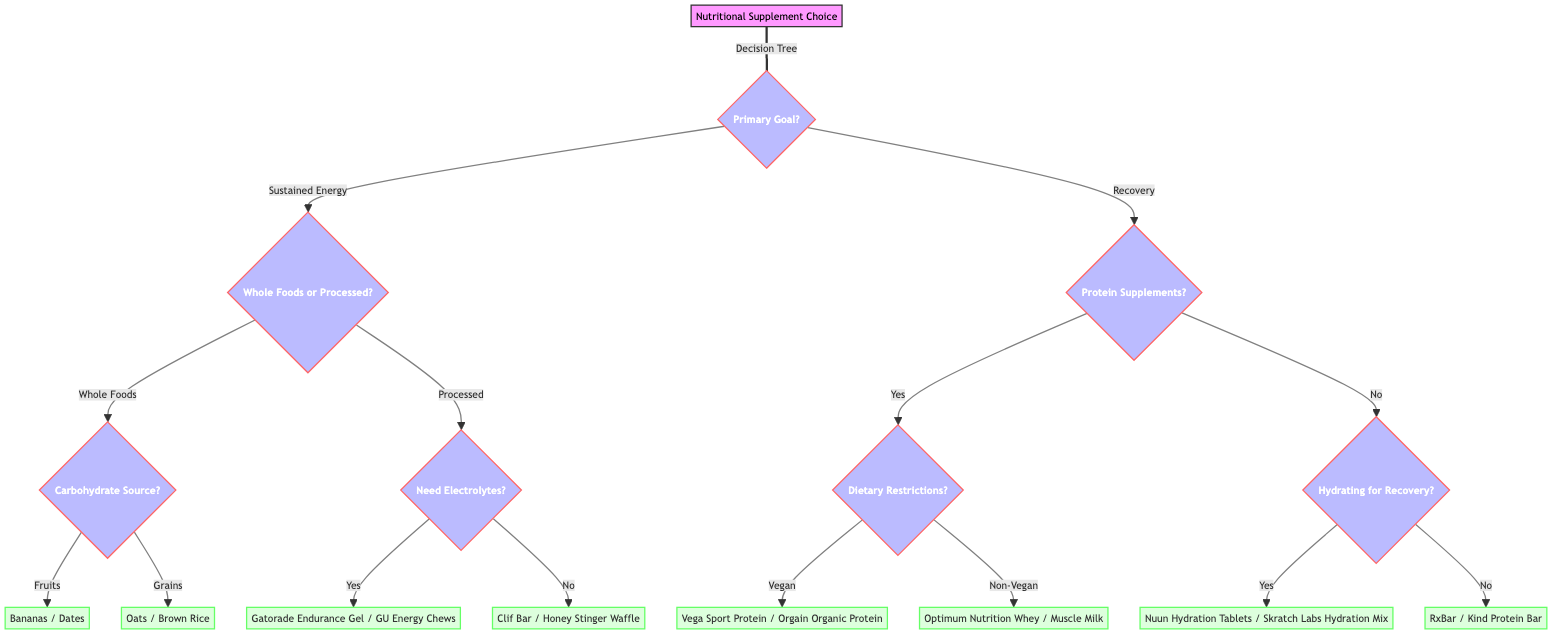What are the two primary goals of the nutritional supplement? The diagram starts with the 'Primary Goal' node, which branches into two main objectives: 'Sustained Energy' and 'Recovery'.
Answer: Sustained Energy, Recovery What type of carbohydrate source can be chosen if 'Whole Foods' is preferred? Following the 'Whole Foods' branch under 'Sustained Energy', it leads to a question asking for the carbohydrate source, which gives two options: 'Fruits' or 'Grains'.
Answer: Fruits, Grains What will you choose if you select 'Processed Supplements' and also need electrolytes? This decision flow moves from 'Processed Supplements' to 'Need Electrolytes?', where you have two outcomes based on the answer. If 'Yes', it leads to the options 'Gatorade Endurance Gel' and 'GU Energy Chews'.
Answer: Gatorade Endurance Gel, GU Energy Chews How many options are provided for fruit sources under 'Whole Foods'? The flow under the 'Whole Foods' section leads to a question that identifies carbohydrate sources specifically for fruit, which results in two choices: 'Bananas' and 'Dates'. Therefore, there are two options provided.
Answer: 2 If someone prefers 'Recovery' and does not want protein supplements, what are their options? In the 'Recovery' segment, if 'No' is selected for protein supplements, it follows to a question about hydration for quick recovery. If 'Yes', the options given are 'Nuun Hydration Tablets' and 'Skratch Labs Hydration Mix'; if 'No', the alternatives are 'RxBar' and 'Kind Protein Bar'. Therefore, the specific options under 'No' are 'RxBar' and 'Kind Protein Bar'.
Answer: RxBar, Kind Protein Bar What happens if a user prefers protein supplements and is vegan? The decision path for someone who prefers protein supplements leads to dietary restrictions. If 'Vegan' is chosen, the subsequent options provided are 'Vega Sport Protein' and 'Orgain Organic Protein'.
Answer: Vega Sport Protein, Orgain Organic Protein How many total basic outcomes are available in the decision tree? The tree provides several end options based on various pathways. Counting all the end options gives a total of 8 distinct supplement choices.
Answer: 8 